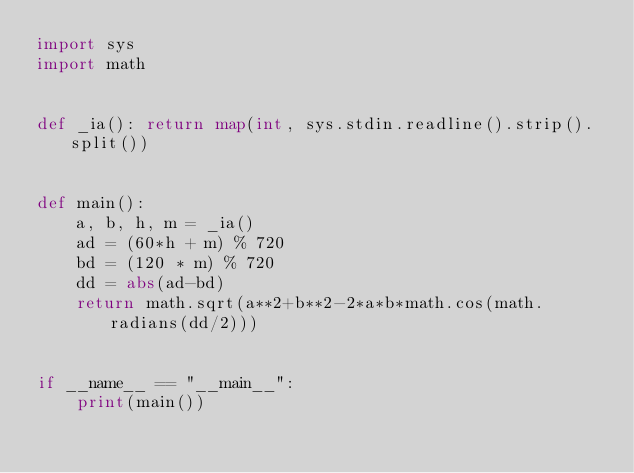<code> <loc_0><loc_0><loc_500><loc_500><_Python_>import sys
import math


def _ia(): return map(int, sys.stdin.readline().strip().split())


def main():
    a, b, h, m = _ia()
    ad = (60*h + m) % 720
    bd = (120 * m) % 720
    dd = abs(ad-bd)
    return math.sqrt(a**2+b**2-2*a*b*math.cos(math.radians(dd/2)))


if __name__ == "__main__":
    print(main())
</code> 